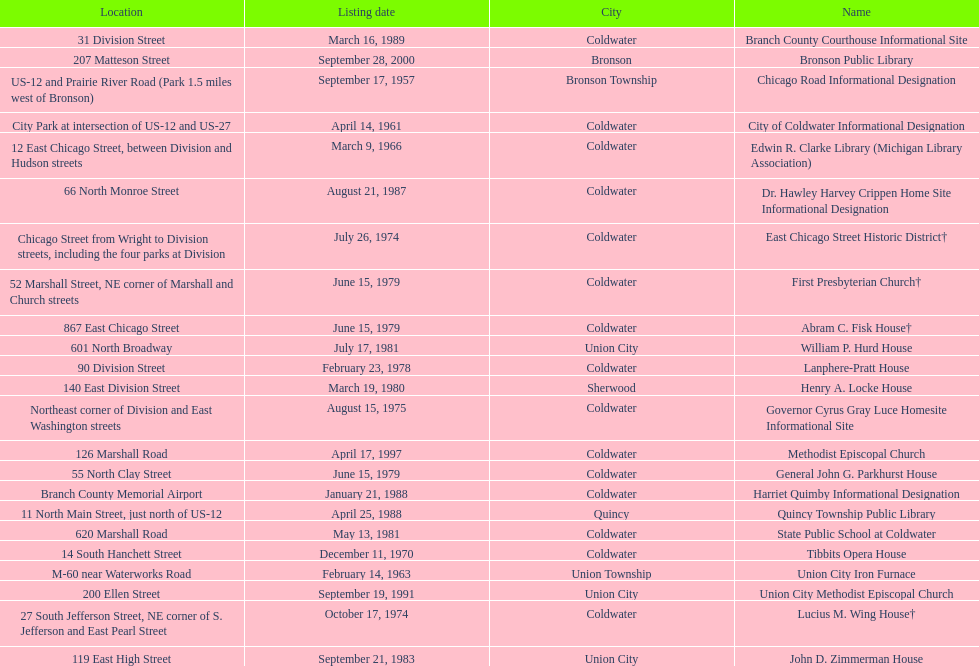I'm looking to parse the entire table for insights. Could you assist me with that? {'header': ['Location', 'Listing date', 'City', 'Name'], 'rows': [['31 Division Street', 'March 16, 1989', 'Coldwater', 'Branch County Courthouse Informational Site'], ['207 Matteson Street', 'September 28, 2000', 'Bronson', 'Bronson Public Library'], ['US-12 and Prairie River Road (Park 1.5 miles west of Bronson)', 'September 17, 1957', 'Bronson Township', 'Chicago Road Informational Designation'], ['City Park at intersection of US-12 and US-27', 'April 14, 1961', 'Coldwater', 'City of Coldwater Informational Designation'], ['12 East Chicago Street, between Division and Hudson streets', 'March 9, 1966', 'Coldwater', 'Edwin R. Clarke Library (Michigan Library Association)'], ['66 North Monroe Street', 'August 21, 1987', 'Coldwater', 'Dr. Hawley Harvey Crippen Home Site Informational Designation'], ['Chicago Street from Wright to Division streets, including the four parks at Division', 'July 26, 1974', 'Coldwater', 'East Chicago Street Historic District†'], ['52 Marshall Street, NE corner of Marshall and Church streets', 'June 15, 1979', 'Coldwater', 'First Presbyterian Church†'], ['867 East Chicago Street', 'June 15, 1979', 'Coldwater', 'Abram C. Fisk House†'], ['601 North Broadway', 'July 17, 1981', 'Union City', 'William P. Hurd House'], ['90 Division Street', 'February 23, 1978', 'Coldwater', 'Lanphere-Pratt House'], ['140 East Division Street', 'March 19, 1980', 'Sherwood', 'Henry A. Locke House'], ['Northeast corner of Division and East Washington streets', 'August 15, 1975', 'Coldwater', 'Governor Cyrus Gray Luce Homesite Informational Site'], ['126 Marshall Road', 'April 17, 1997', 'Coldwater', 'Methodist Episcopal Church'], ['55 North Clay Street', 'June 15, 1979', 'Coldwater', 'General John G. Parkhurst House'], ['Branch County Memorial Airport', 'January 21, 1988', 'Coldwater', 'Harriet Quimby Informational Designation'], ['11 North Main Street, just north of US-12', 'April 25, 1988', 'Quincy', 'Quincy Township Public Library'], ['620 Marshall Road', 'May 13, 1981', 'Coldwater', 'State Public School at Coldwater'], ['14 South Hanchett Street', 'December 11, 1970', 'Coldwater', 'Tibbits Opera House'], ['M-60 near Waterworks Road', 'February 14, 1963', 'Union Township', 'Union City Iron Furnace'], ['200 Ellen Street', 'September 19, 1991', 'Union City', 'Union City Methodist Episcopal Church'], ['27 South Jefferson Street, NE corner of S. Jefferson and East Pearl Street', 'October 17, 1974', 'Coldwater', 'Lucius M. Wing House†'], ['119 East High Street', 'September 21, 1983', 'Union City', 'John D. Zimmerman House']]} Which site was listed earlier, the state public school or the edwin r. clarke library? Edwin R. Clarke Library. 